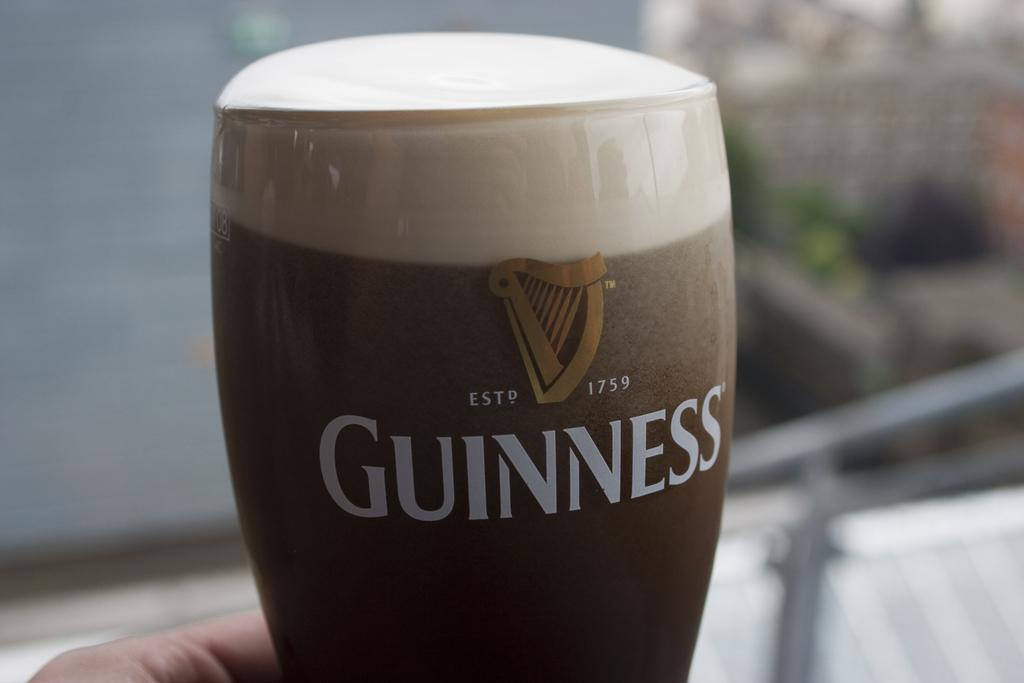Provide a one-sentence caption for the provided image. A person holds a glass of Guinness beer. 